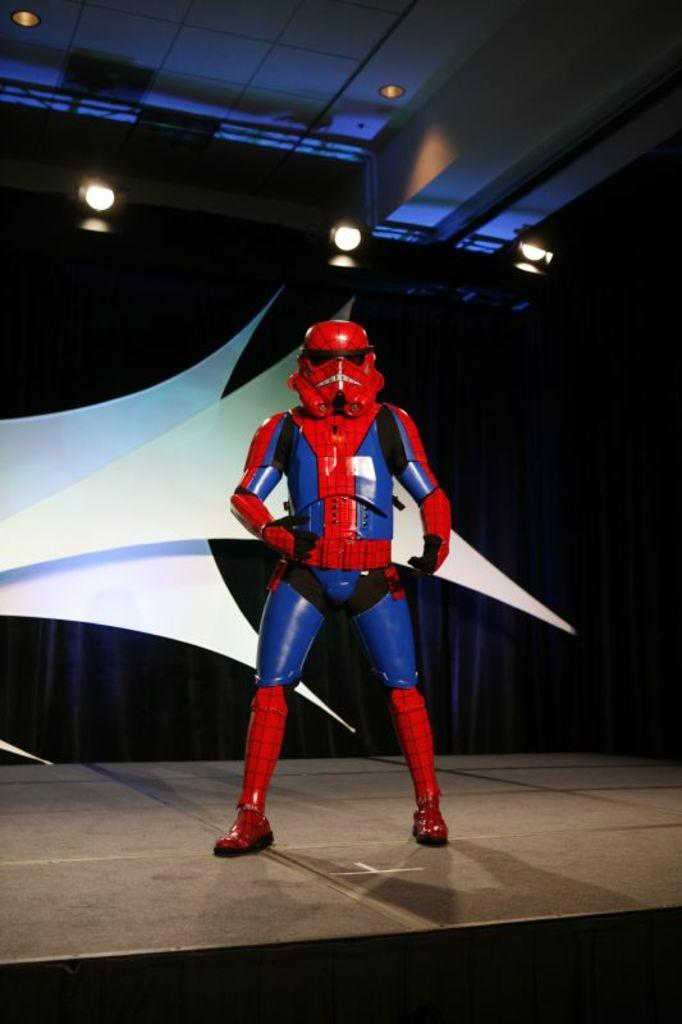What is the person in the image doing? The person is standing on the stage. What is the person wearing on their face? The person is wearing a mask. What is located behind the person on the stage? There is a curtain behind the person. What can be seen attached to the roof in the image? Lights are attached to the roof. Can you tell me how many watches are visible in the image? There are no watches present in the image. What type of harbor can be seen in the background of the image? There is no harbor present in the image; it features a person on a stage with a curtain and lights. 